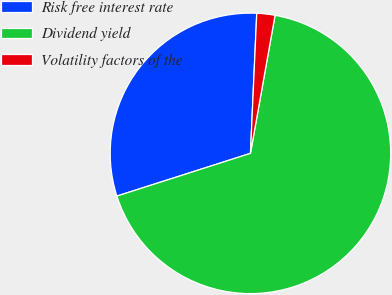Convert chart. <chart><loc_0><loc_0><loc_500><loc_500><pie_chart><fcel>Risk free interest rate<fcel>Dividend yield<fcel>Volatility factors of the<nl><fcel>30.64%<fcel>67.26%<fcel>2.09%<nl></chart> 